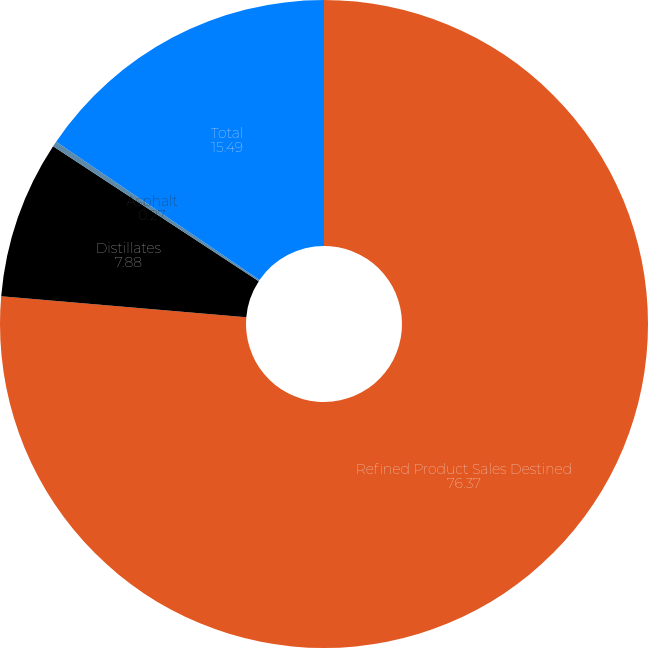<chart> <loc_0><loc_0><loc_500><loc_500><pie_chart><fcel>Refined Product Sales Destined<fcel>Distillates<fcel>Asphalt<fcel>Total<nl><fcel>76.37%<fcel>7.88%<fcel>0.27%<fcel>15.49%<nl></chart> 